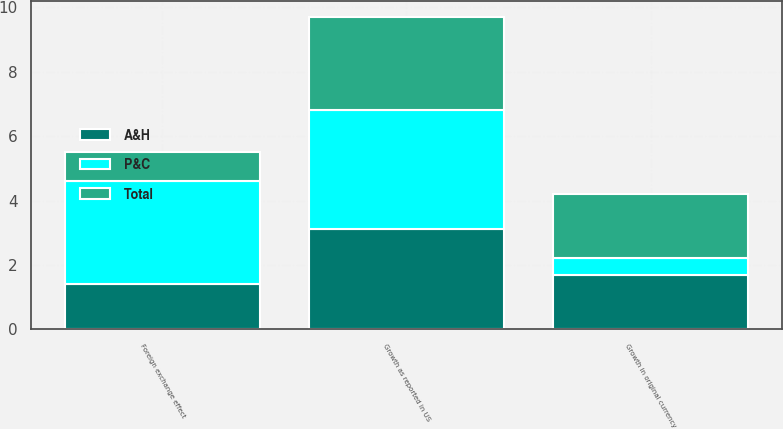Convert chart. <chart><loc_0><loc_0><loc_500><loc_500><stacked_bar_chart><ecel><fcel>Growth in original currency<fcel>Foreign exchange effect<fcel>Growth as reported in US<nl><fcel>Total<fcel>2<fcel>0.9<fcel>2.9<nl><fcel>P&C<fcel>0.5<fcel>3.2<fcel>3.7<nl><fcel>A&H<fcel>1.7<fcel>1.4<fcel>3.1<nl></chart> 